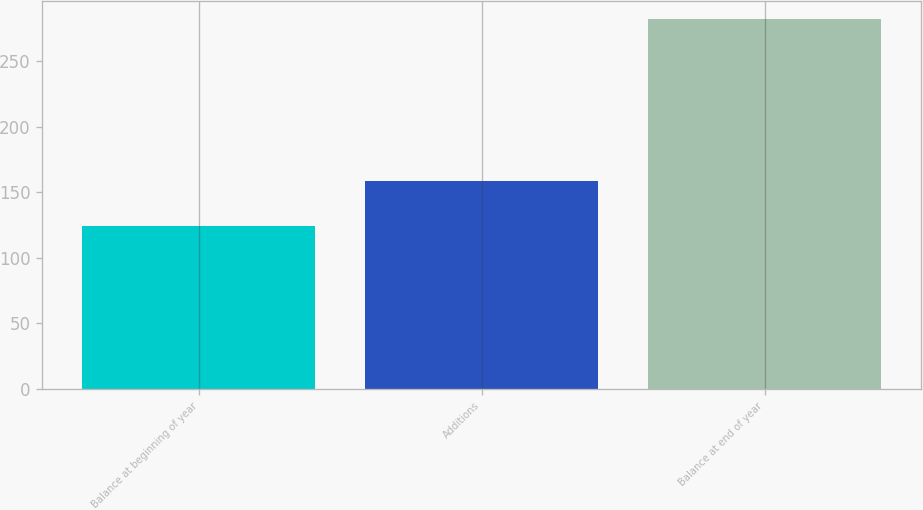Convert chart. <chart><loc_0><loc_0><loc_500><loc_500><bar_chart><fcel>Balance at beginning of year<fcel>Additions<fcel>Balance at end of year<nl><fcel>124<fcel>159<fcel>282<nl></chart> 